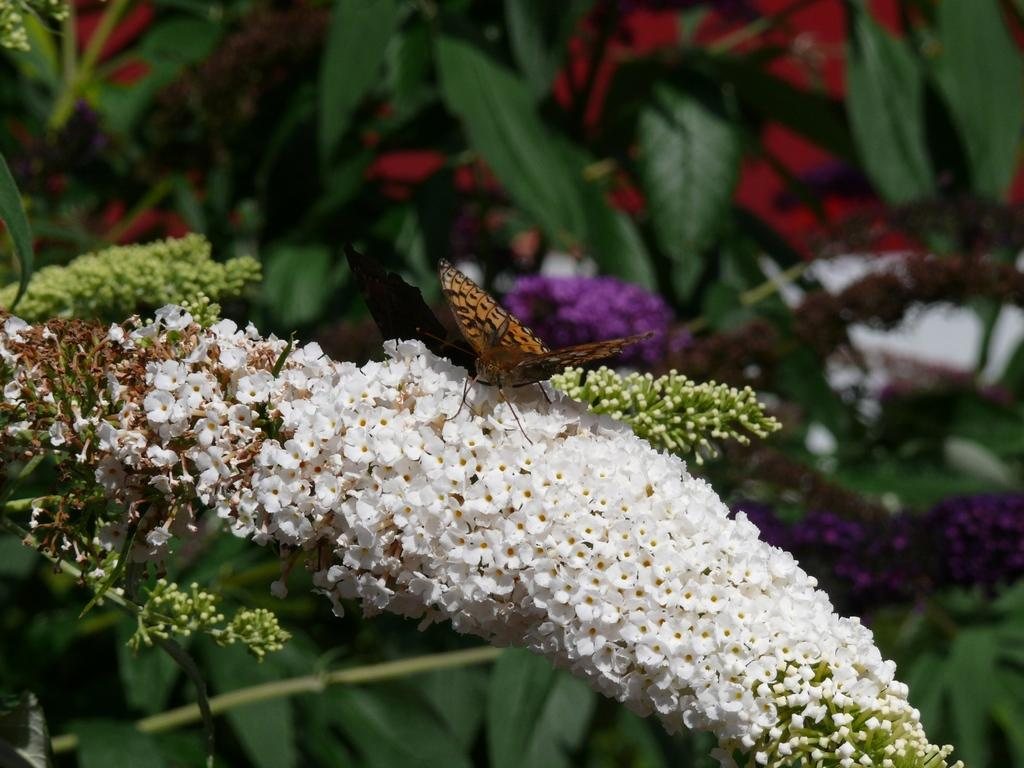What type of flowers are present in the image? There are white color flowers in the image. Is there any other living creature visible in the image? Yes, there is a butterfly on the flowers. What can be seen in the background of the image? There are flowers and leaves in the background of the image. How is the background of the image depicted? The background is blurred. What type of wood is used to make the birthday cake stand in the image? There is no birthday cake stand present in the image, and therefore no wood can be identified. 